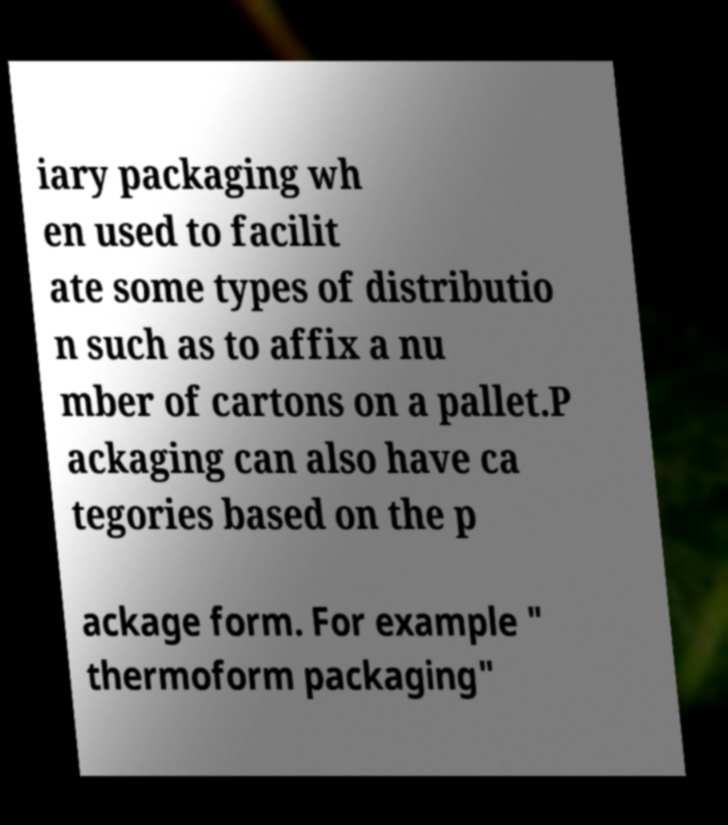For documentation purposes, I need the text within this image transcribed. Could you provide that? iary packaging wh en used to facilit ate some types of distributio n such as to affix a nu mber of cartons on a pallet.P ackaging can also have ca tegories based on the p ackage form. For example " thermoform packaging" 